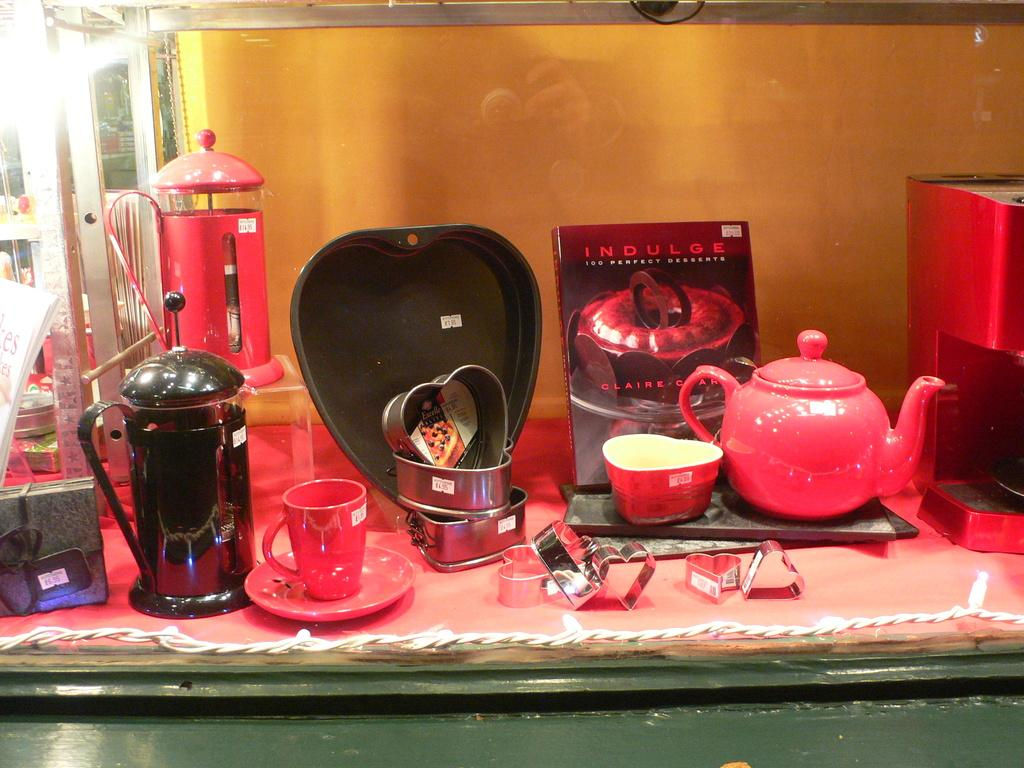<image>
Create a compact narrative representing the image presented. A book titled Indulge is behind a tea pot. 